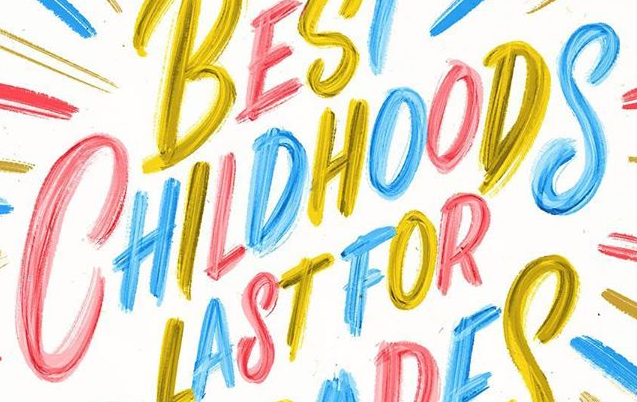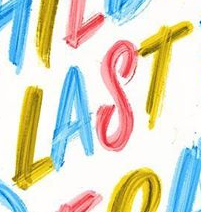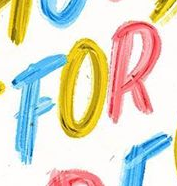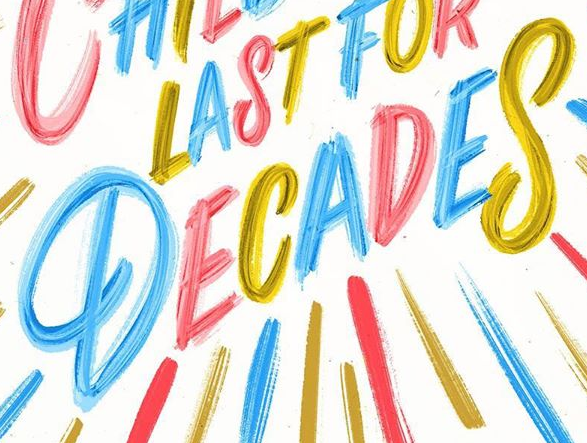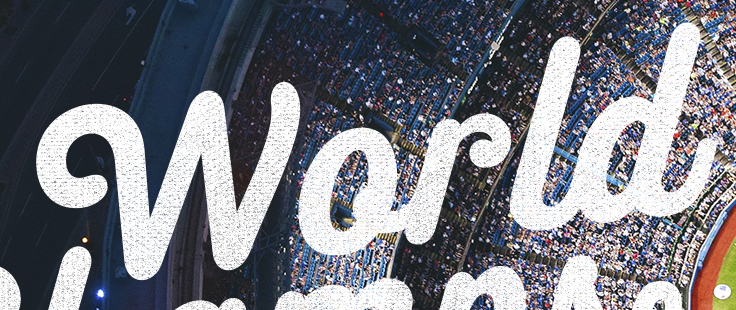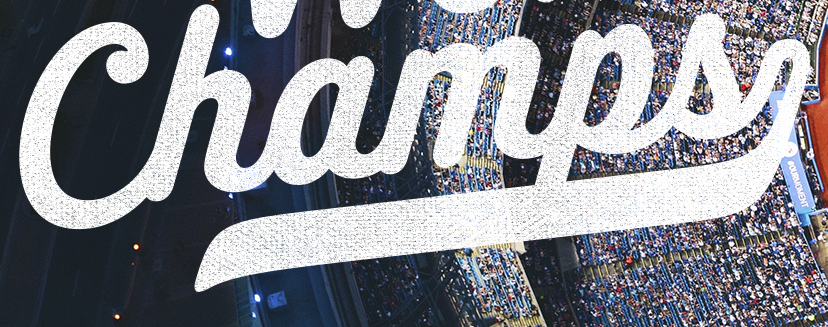What words are shown in these images in order, separated by a semicolon? CHILDHOODS; LAST; FOR; DECADES; World; Champs 